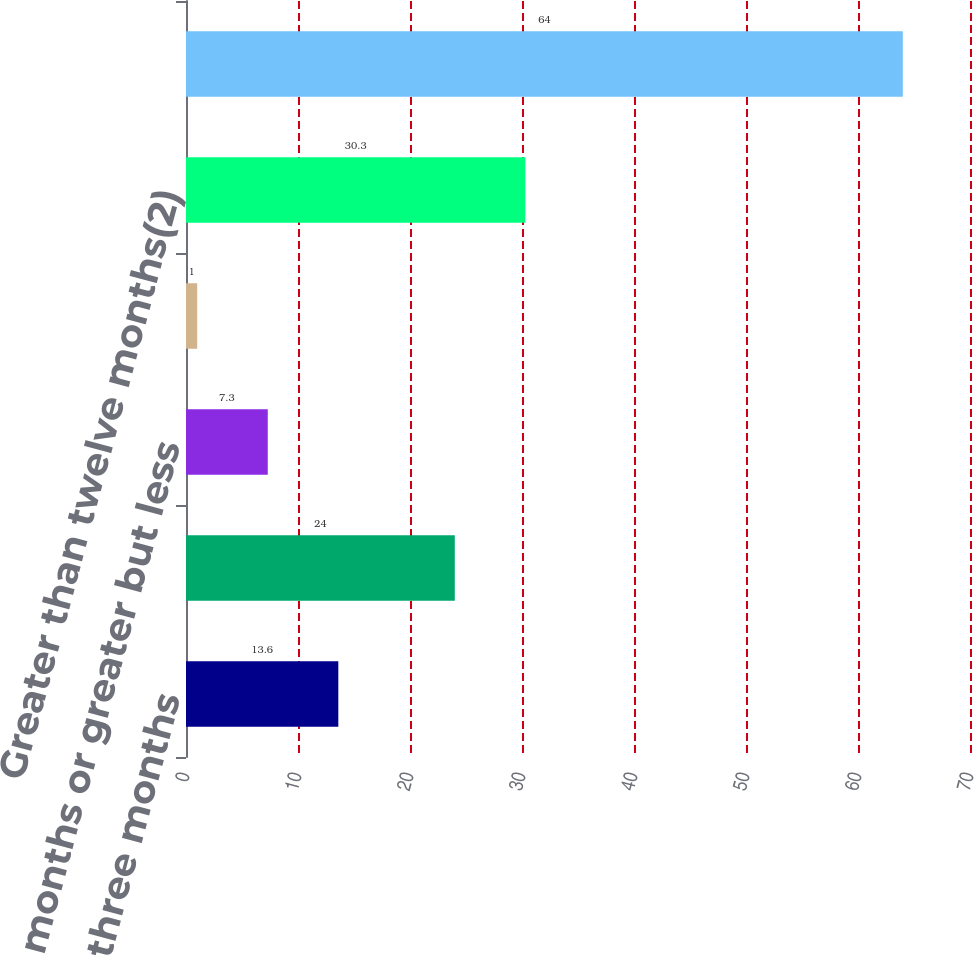<chart> <loc_0><loc_0><loc_500><loc_500><bar_chart><fcel>Less than three months<fcel>Three months or greater but<fcel>Six months or greater but less<fcel>Nine months or greater but<fcel>Greater than twelve months(2)<fcel>Total<nl><fcel>13.6<fcel>24<fcel>7.3<fcel>1<fcel>30.3<fcel>64<nl></chart> 